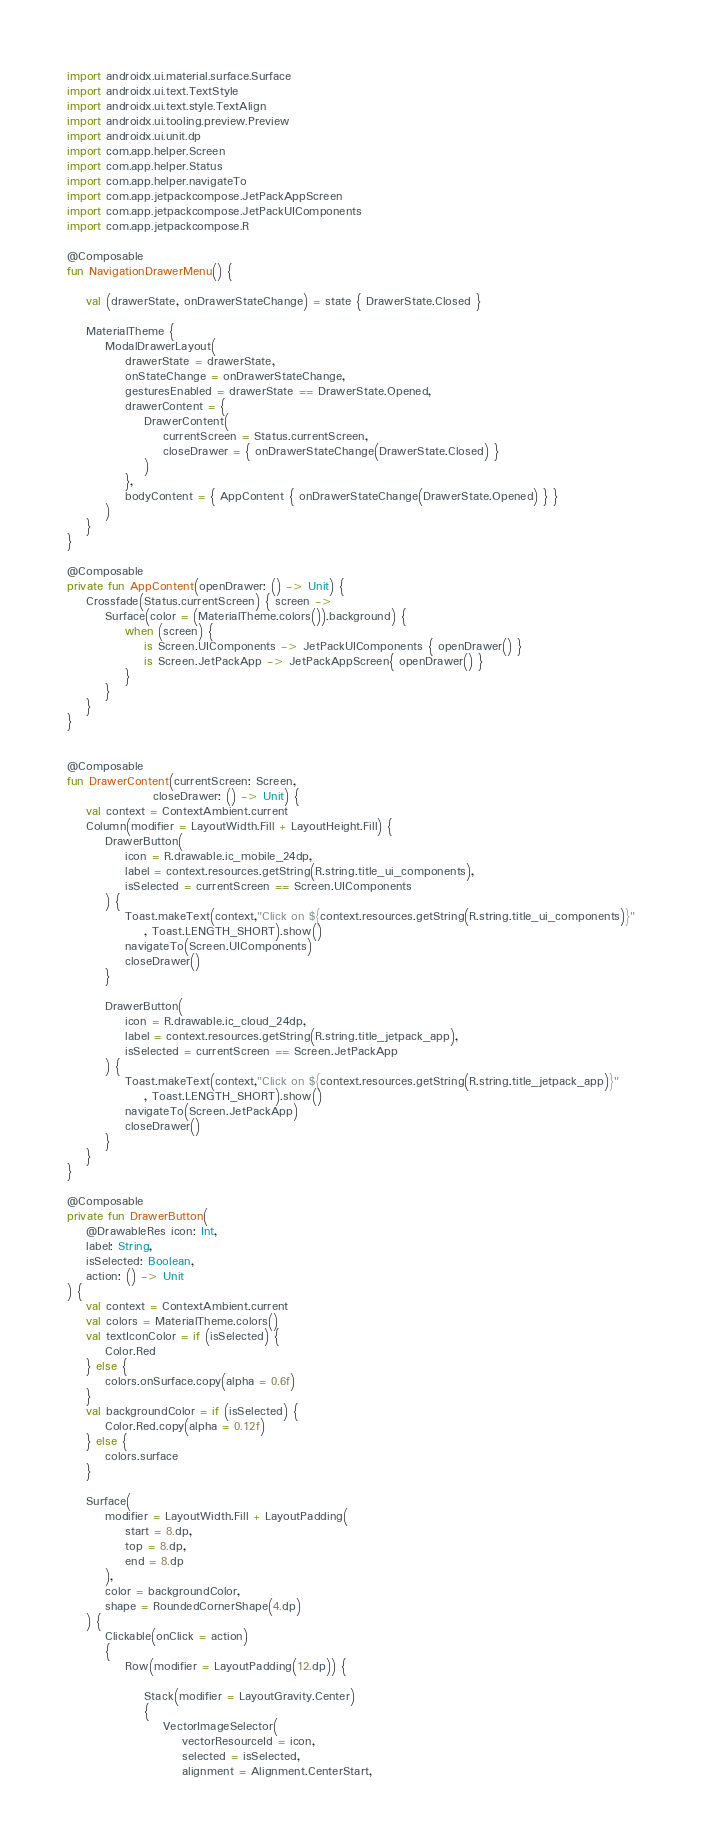<code> <loc_0><loc_0><loc_500><loc_500><_Kotlin_>import androidx.ui.material.surface.Surface
import androidx.ui.text.TextStyle
import androidx.ui.text.style.TextAlign
import androidx.ui.tooling.preview.Preview
import androidx.ui.unit.dp
import com.app.helper.Screen
import com.app.helper.Status
import com.app.helper.navigateTo
import com.app.jetpackcompose.JetPackAppScreen
import com.app.jetpackcompose.JetPackUIComponents
import com.app.jetpackcompose.R

@Composable
fun NavigationDrawerMenu() {

    val (drawerState, onDrawerStateChange) = state { DrawerState.Closed }

    MaterialTheme {
        ModalDrawerLayout(
            drawerState = drawerState,
            onStateChange = onDrawerStateChange,
            gesturesEnabled = drawerState == DrawerState.Opened,
            drawerContent = {
                DrawerContent(
                    currentScreen = Status.currentScreen,
                    closeDrawer = { onDrawerStateChange(DrawerState.Closed) }
                )
            },
            bodyContent = { AppContent { onDrawerStateChange(DrawerState.Opened) } }
        )
    }
}

@Composable
private fun AppContent(openDrawer: () -> Unit) {
    Crossfade(Status.currentScreen) { screen ->
        Surface(color = (MaterialTheme.colors()).background) {
            when (screen) {
                is Screen.UIComponents -> JetPackUIComponents { openDrawer() }
                is Screen.JetPackApp -> JetPackAppScreen{ openDrawer() }
            }
        }
    }
}


@Composable
fun DrawerContent(currentScreen: Screen,
                  closeDrawer: () -> Unit) {
    val context = ContextAmbient.current
    Column(modifier = LayoutWidth.Fill + LayoutHeight.Fill) {
        DrawerButton(
            icon = R.drawable.ic_mobile_24dp,
            label = context.resources.getString(R.string.title_ui_components),
            isSelected = currentScreen == Screen.UIComponents
        ) {
            Toast.makeText(context,"Click on ${context.resources.getString(R.string.title_ui_components)}"
                , Toast.LENGTH_SHORT).show()
            navigateTo(Screen.UIComponents)
            closeDrawer()
        }

        DrawerButton(
            icon = R.drawable.ic_cloud_24dp,
            label = context.resources.getString(R.string.title_jetpack_app),
            isSelected = currentScreen == Screen.JetPackApp
        ) {
            Toast.makeText(context,"Click on ${context.resources.getString(R.string.title_jetpack_app)}"
                , Toast.LENGTH_SHORT).show()
            navigateTo(Screen.JetPackApp)
            closeDrawer()
        }
    }
}

@Composable
private fun DrawerButton(
    @DrawableRes icon: Int,
    label: String,
    isSelected: Boolean,
    action: () -> Unit
) {
    val context = ContextAmbient.current
    val colors = MaterialTheme.colors()
    val textIconColor = if (isSelected) {
        Color.Red
    } else {
        colors.onSurface.copy(alpha = 0.6f)
    }
    val backgroundColor = if (isSelected) {
        Color.Red.copy(alpha = 0.12f)
    } else {
        colors.surface
    }

    Surface(
        modifier = LayoutWidth.Fill + LayoutPadding(
            start = 8.dp,
            top = 8.dp,
            end = 8.dp
        ),
        color = backgroundColor,
        shape = RoundedCornerShape(4.dp)
    ) {
        Clickable(onClick = action)
        {
            Row(modifier = LayoutPadding(12.dp)) {

                Stack(modifier = LayoutGravity.Center)
                {
                    VectorImageSelector(
                        vectorResourceId = icon,
                        selected = isSelected,
                        alignment = Alignment.CenterStart,</code> 